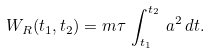<formula> <loc_0><loc_0><loc_500><loc_500>W _ { R } ( t _ { 1 } , t _ { 2 } ) = m \tau \, \int _ { t _ { 1 } } ^ { t _ { 2 } } \, a ^ { 2 } \, d t .</formula> 